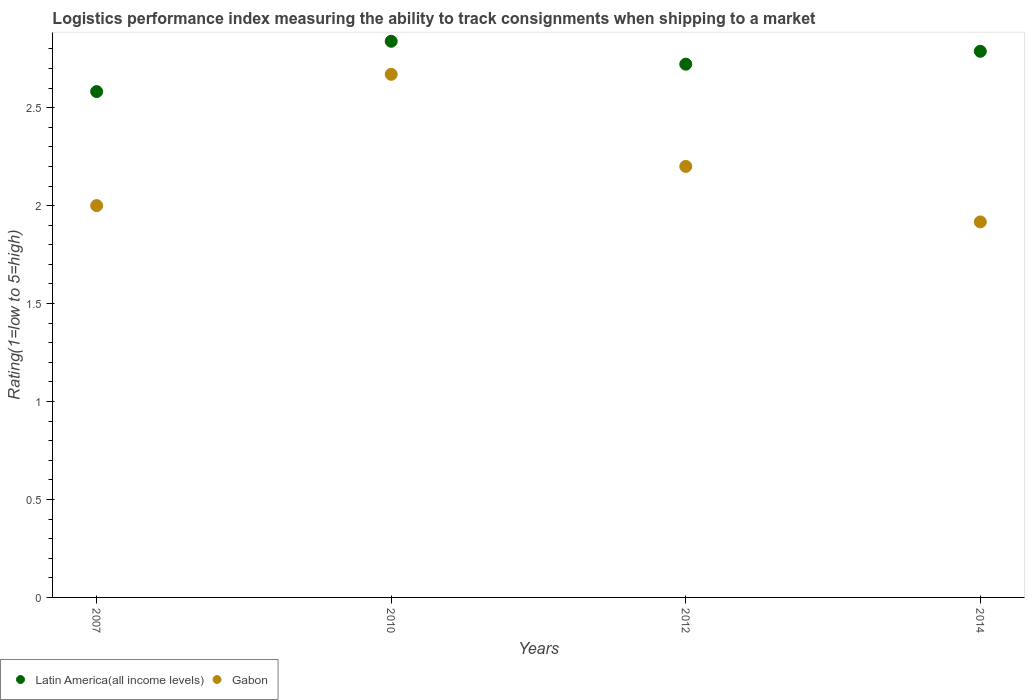Is the number of dotlines equal to the number of legend labels?
Your response must be concise. Yes. What is the Logistic performance index in Latin America(all income levels) in 2007?
Your answer should be compact. 2.58. Across all years, what is the maximum Logistic performance index in Latin America(all income levels)?
Keep it short and to the point. 2.84. Across all years, what is the minimum Logistic performance index in Gabon?
Your answer should be very brief. 1.92. In which year was the Logistic performance index in Gabon minimum?
Provide a short and direct response. 2014. What is the total Logistic performance index in Latin America(all income levels) in the graph?
Provide a short and direct response. 10.93. What is the difference between the Logistic performance index in Gabon in 2010 and that in 2012?
Your answer should be very brief. 0.47. What is the difference between the Logistic performance index in Gabon in 2014 and the Logistic performance index in Latin America(all income levels) in 2007?
Keep it short and to the point. -0.67. What is the average Logistic performance index in Latin America(all income levels) per year?
Ensure brevity in your answer.  2.73. In the year 2014, what is the difference between the Logistic performance index in Latin America(all income levels) and Logistic performance index in Gabon?
Provide a succinct answer. 0.87. What is the ratio of the Logistic performance index in Gabon in 2007 to that in 2014?
Offer a terse response. 1.04. What is the difference between the highest and the second highest Logistic performance index in Gabon?
Ensure brevity in your answer.  0.47. What is the difference between the highest and the lowest Logistic performance index in Gabon?
Offer a very short reply. 0.75. In how many years, is the Logistic performance index in Latin America(all income levels) greater than the average Logistic performance index in Latin America(all income levels) taken over all years?
Keep it short and to the point. 2. Is the sum of the Logistic performance index in Gabon in 2010 and 2012 greater than the maximum Logistic performance index in Latin America(all income levels) across all years?
Provide a succinct answer. Yes. Does the Logistic performance index in Latin America(all income levels) monotonically increase over the years?
Provide a short and direct response. No. Is the Logistic performance index in Latin America(all income levels) strictly less than the Logistic performance index in Gabon over the years?
Offer a terse response. No. How many dotlines are there?
Your answer should be compact. 2. Does the graph contain grids?
Keep it short and to the point. No. Where does the legend appear in the graph?
Give a very brief answer. Bottom left. How are the legend labels stacked?
Keep it short and to the point. Horizontal. What is the title of the graph?
Give a very brief answer. Logistics performance index measuring the ability to track consignments when shipping to a market. Does "Iran" appear as one of the legend labels in the graph?
Offer a terse response. No. What is the label or title of the X-axis?
Keep it short and to the point. Years. What is the label or title of the Y-axis?
Your answer should be very brief. Rating(1=low to 5=high). What is the Rating(1=low to 5=high) of Latin America(all income levels) in 2007?
Offer a very short reply. 2.58. What is the Rating(1=low to 5=high) in Gabon in 2007?
Ensure brevity in your answer.  2. What is the Rating(1=low to 5=high) in Latin America(all income levels) in 2010?
Make the answer very short. 2.84. What is the Rating(1=low to 5=high) of Gabon in 2010?
Your answer should be compact. 2.67. What is the Rating(1=low to 5=high) of Latin America(all income levels) in 2012?
Offer a very short reply. 2.72. What is the Rating(1=low to 5=high) in Latin America(all income levels) in 2014?
Your response must be concise. 2.79. What is the Rating(1=low to 5=high) in Gabon in 2014?
Keep it short and to the point. 1.92. Across all years, what is the maximum Rating(1=low to 5=high) of Latin America(all income levels)?
Provide a short and direct response. 2.84. Across all years, what is the maximum Rating(1=low to 5=high) of Gabon?
Offer a terse response. 2.67. Across all years, what is the minimum Rating(1=low to 5=high) of Latin America(all income levels)?
Provide a short and direct response. 2.58. Across all years, what is the minimum Rating(1=low to 5=high) in Gabon?
Give a very brief answer. 1.92. What is the total Rating(1=low to 5=high) in Latin America(all income levels) in the graph?
Offer a terse response. 10.93. What is the total Rating(1=low to 5=high) of Gabon in the graph?
Provide a succinct answer. 8.79. What is the difference between the Rating(1=low to 5=high) in Latin America(all income levels) in 2007 and that in 2010?
Your answer should be very brief. -0.26. What is the difference between the Rating(1=low to 5=high) in Gabon in 2007 and that in 2010?
Your answer should be very brief. -0.67. What is the difference between the Rating(1=low to 5=high) in Latin America(all income levels) in 2007 and that in 2012?
Provide a short and direct response. -0.14. What is the difference between the Rating(1=low to 5=high) in Latin America(all income levels) in 2007 and that in 2014?
Offer a terse response. -0.21. What is the difference between the Rating(1=low to 5=high) in Gabon in 2007 and that in 2014?
Your answer should be compact. 0.08. What is the difference between the Rating(1=low to 5=high) of Latin America(all income levels) in 2010 and that in 2012?
Offer a terse response. 0.12. What is the difference between the Rating(1=low to 5=high) of Gabon in 2010 and that in 2012?
Provide a succinct answer. 0.47. What is the difference between the Rating(1=low to 5=high) in Latin America(all income levels) in 2010 and that in 2014?
Make the answer very short. 0.05. What is the difference between the Rating(1=low to 5=high) of Gabon in 2010 and that in 2014?
Your response must be concise. 0.75. What is the difference between the Rating(1=low to 5=high) in Latin America(all income levels) in 2012 and that in 2014?
Your answer should be very brief. -0.07. What is the difference between the Rating(1=low to 5=high) of Gabon in 2012 and that in 2014?
Your response must be concise. 0.28. What is the difference between the Rating(1=low to 5=high) in Latin America(all income levels) in 2007 and the Rating(1=low to 5=high) in Gabon in 2010?
Offer a very short reply. -0.09. What is the difference between the Rating(1=low to 5=high) in Latin America(all income levels) in 2007 and the Rating(1=low to 5=high) in Gabon in 2012?
Make the answer very short. 0.38. What is the difference between the Rating(1=low to 5=high) in Latin America(all income levels) in 2007 and the Rating(1=low to 5=high) in Gabon in 2014?
Give a very brief answer. 0.67. What is the difference between the Rating(1=low to 5=high) in Latin America(all income levels) in 2010 and the Rating(1=low to 5=high) in Gabon in 2012?
Give a very brief answer. 0.64. What is the difference between the Rating(1=low to 5=high) of Latin America(all income levels) in 2010 and the Rating(1=low to 5=high) of Gabon in 2014?
Your response must be concise. 0.92. What is the difference between the Rating(1=low to 5=high) of Latin America(all income levels) in 2012 and the Rating(1=low to 5=high) of Gabon in 2014?
Offer a very short reply. 0.81. What is the average Rating(1=low to 5=high) in Latin America(all income levels) per year?
Ensure brevity in your answer.  2.73. What is the average Rating(1=low to 5=high) in Gabon per year?
Offer a very short reply. 2.2. In the year 2007, what is the difference between the Rating(1=low to 5=high) in Latin America(all income levels) and Rating(1=low to 5=high) in Gabon?
Ensure brevity in your answer.  0.58. In the year 2010, what is the difference between the Rating(1=low to 5=high) in Latin America(all income levels) and Rating(1=low to 5=high) in Gabon?
Offer a terse response. 0.17. In the year 2012, what is the difference between the Rating(1=low to 5=high) of Latin America(all income levels) and Rating(1=low to 5=high) of Gabon?
Your response must be concise. 0.52. In the year 2014, what is the difference between the Rating(1=low to 5=high) of Latin America(all income levels) and Rating(1=low to 5=high) of Gabon?
Give a very brief answer. 0.87. What is the ratio of the Rating(1=low to 5=high) of Latin America(all income levels) in 2007 to that in 2010?
Provide a succinct answer. 0.91. What is the ratio of the Rating(1=low to 5=high) in Gabon in 2007 to that in 2010?
Keep it short and to the point. 0.75. What is the ratio of the Rating(1=low to 5=high) in Latin America(all income levels) in 2007 to that in 2012?
Ensure brevity in your answer.  0.95. What is the ratio of the Rating(1=low to 5=high) of Gabon in 2007 to that in 2012?
Provide a succinct answer. 0.91. What is the ratio of the Rating(1=low to 5=high) in Latin America(all income levels) in 2007 to that in 2014?
Make the answer very short. 0.93. What is the ratio of the Rating(1=low to 5=high) in Gabon in 2007 to that in 2014?
Make the answer very short. 1.04. What is the ratio of the Rating(1=low to 5=high) of Latin America(all income levels) in 2010 to that in 2012?
Give a very brief answer. 1.04. What is the ratio of the Rating(1=low to 5=high) of Gabon in 2010 to that in 2012?
Your answer should be very brief. 1.21. What is the ratio of the Rating(1=low to 5=high) in Latin America(all income levels) in 2010 to that in 2014?
Offer a terse response. 1.02. What is the ratio of the Rating(1=low to 5=high) of Gabon in 2010 to that in 2014?
Your answer should be compact. 1.39. What is the ratio of the Rating(1=low to 5=high) in Latin America(all income levels) in 2012 to that in 2014?
Offer a terse response. 0.98. What is the ratio of the Rating(1=low to 5=high) of Gabon in 2012 to that in 2014?
Keep it short and to the point. 1.15. What is the difference between the highest and the second highest Rating(1=low to 5=high) of Latin America(all income levels)?
Your answer should be very brief. 0.05. What is the difference between the highest and the second highest Rating(1=low to 5=high) in Gabon?
Provide a short and direct response. 0.47. What is the difference between the highest and the lowest Rating(1=low to 5=high) of Latin America(all income levels)?
Keep it short and to the point. 0.26. What is the difference between the highest and the lowest Rating(1=low to 5=high) in Gabon?
Offer a very short reply. 0.75. 